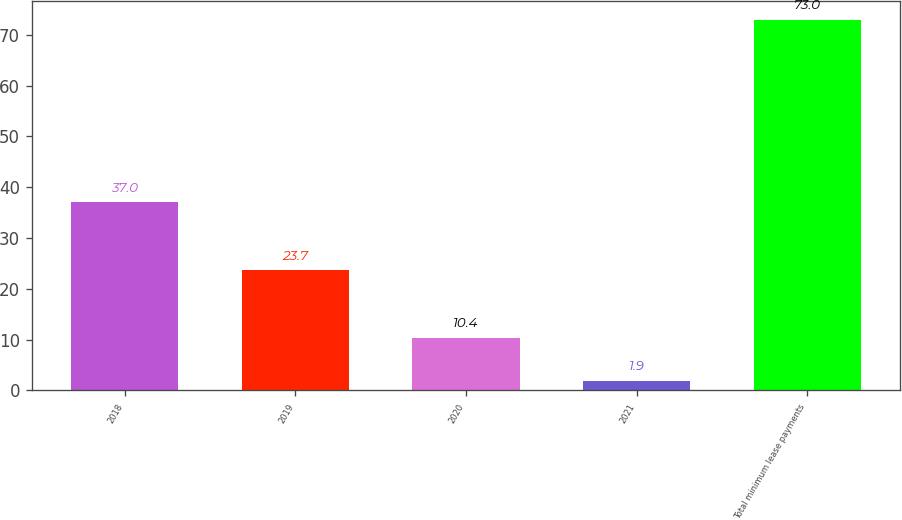Convert chart to OTSL. <chart><loc_0><loc_0><loc_500><loc_500><bar_chart><fcel>2018<fcel>2019<fcel>2020<fcel>2021<fcel>Total minimum lease payments<nl><fcel>37<fcel>23.7<fcel>10.4<fcel>1.9<fcel>73<nl></chart> 